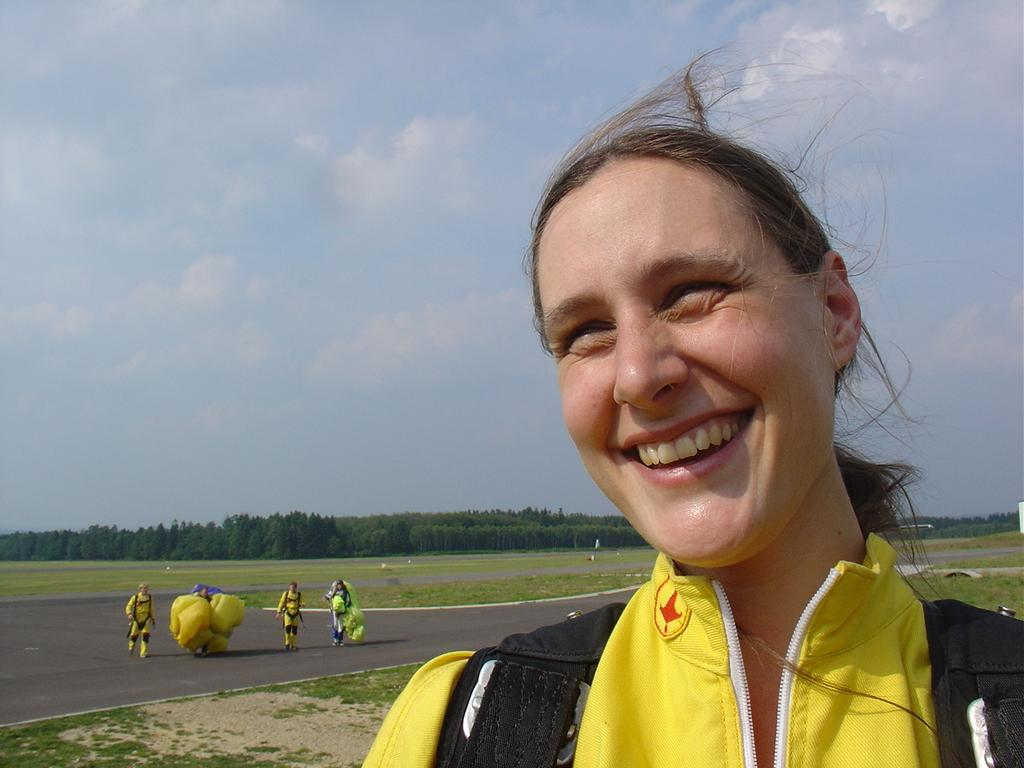What can be seen in the image related to people? There are persons wearing clothes in the image. What is located in the middle of the image? There are trees in the middle of the image. What is visible at the top of the image? The sky is visible at the top of the image. What level of reading ability do the trees in the image possess? The trees in the image do not possess any reading ability, as they are inanimate objects. 